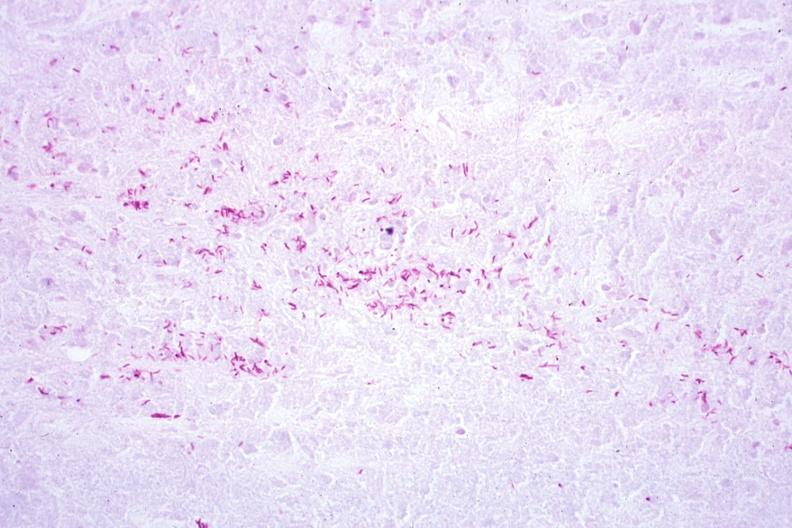s tuberculosis present?
Answer the question using a single word or phrase. Yes 